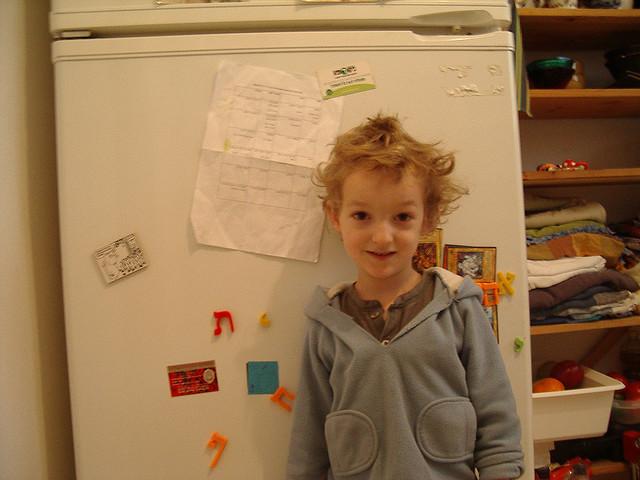What is looking at you?
Keep it brief. Child. What do you think the temperature is in this room?
Quick response, please. Cold. Is the boy wearing suspenders?
Give a very brief answer. No. Is this person an adult?
Concise answer only. No. Can you see fruits in the picture?
Give a very brief answer. Yes. What color is the child's sweater?
Short answer required. Gray. Does this person have a tattoo?
Write a very short answer. No. Who is standing in front of the refrigerator?
Concise answer only. Boy. What appliance is she standing next to?
Give a very brief answer. Refrigerator. 